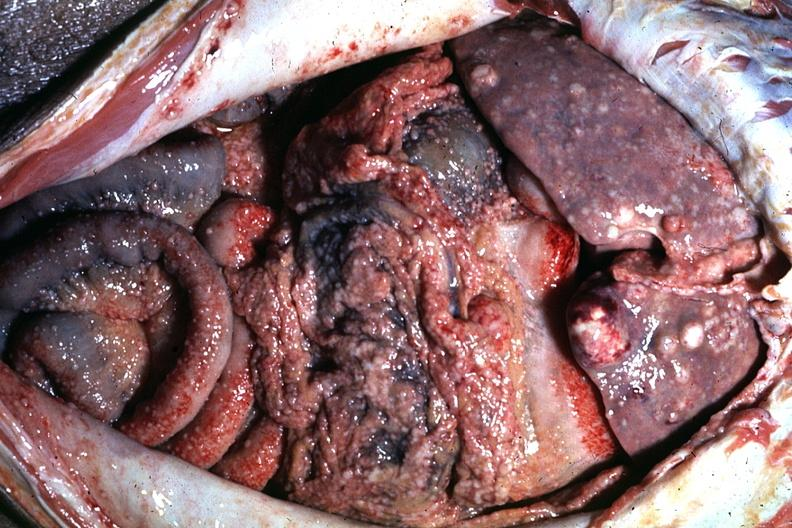does abdomen show excellent?
Answer the question using a single word or phrase. No 